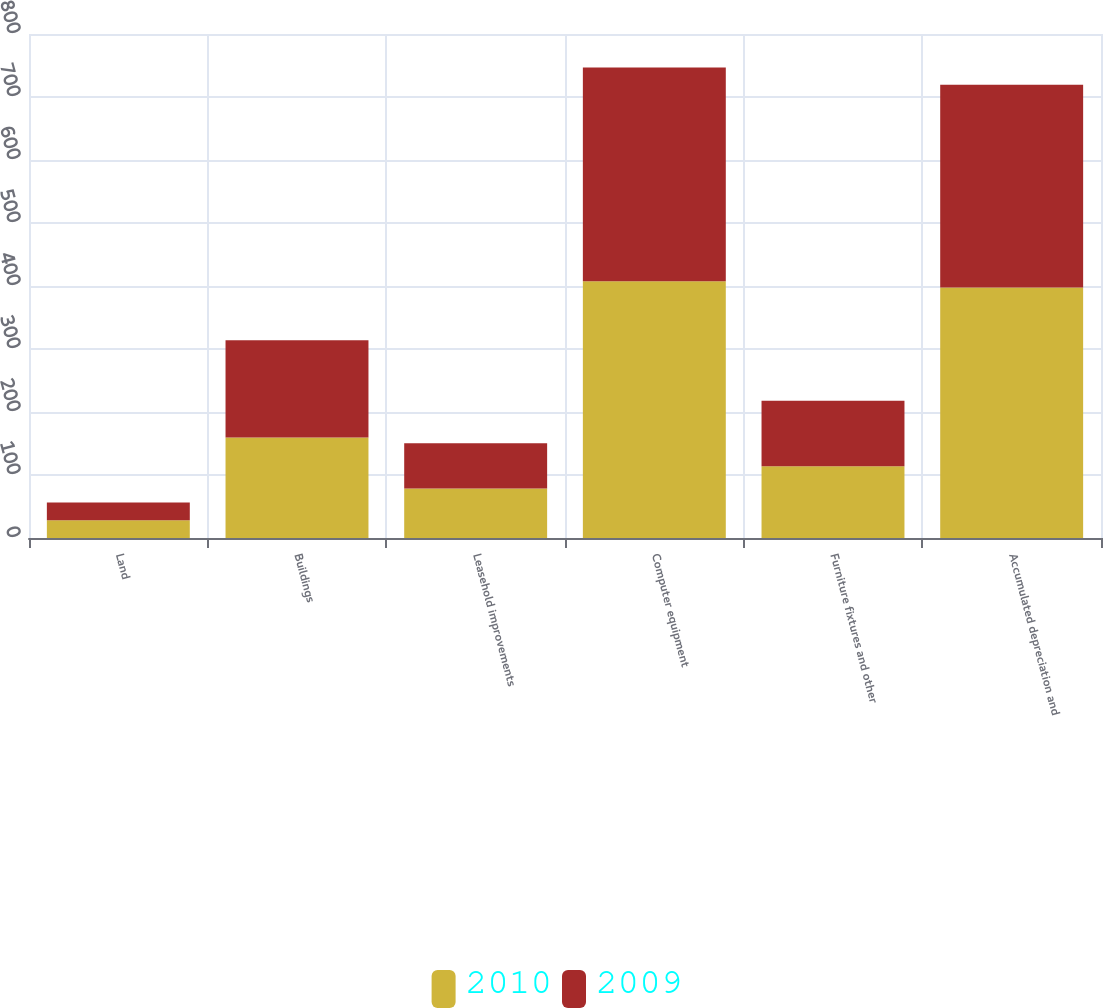Convert chart. <chart><loc_0><loc_0><loc_500><loc_500><stacked_bar_chart><ecel><fcel>Land<fcel>Buildings<fcel>Leasehold improvements<fcel>Computer equipment<fcel>Furniture fixtures and other<fcel>Accumulated depreciation and<nl><fcel>2010<fcel>28<fcel>159.7<fcel>78.5<fcel>407.4<fcel>114<fcel>397.6<nl><fcel>2009<fcel>28.2<fcel>154.3<fcel>72<fcel>339.3<fcel>103.8<fcel>321.7<nl></chart> 